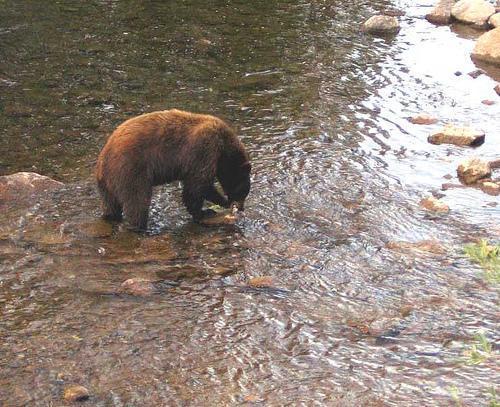How many bears are there?
Give a very brief answer. 1. 